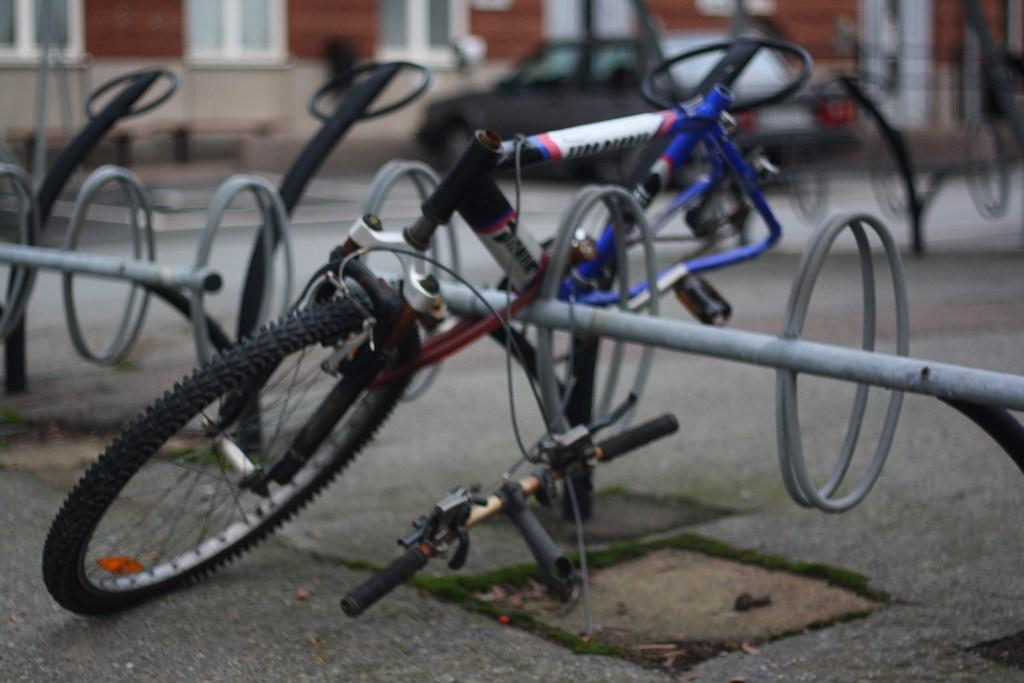What type of items are visible on the floor in the image? There are spare parts of a bicycle in the image. Can you describe the location of the spare parts in the image? The spare parts are on the floor. What type of religious symbol can be seen in the image? There is no religious symbol present in the image; it only contains spare parts of a bicycle on the floor. 